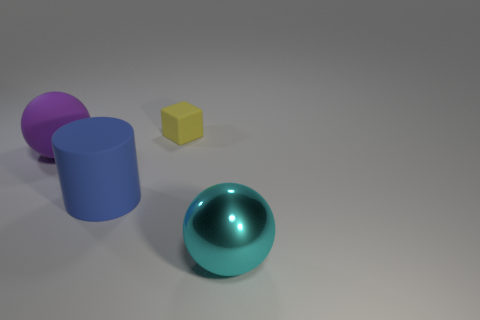Is the number of purple rubber things that are behind the small object the same as the number of matte cubes that are in front of the big blue cylinder? After closely examining the image, it appears that there is only one purple rubber item, which can be seen behind the small yellow cube. Also, in front of the large blue cylinder, I can confirm there is just one matte cube. Therefore, the number of purple rubber items behind the small object is indeed the same as the number of matte cubes in front of the big blue cylinder: a single item of each. 